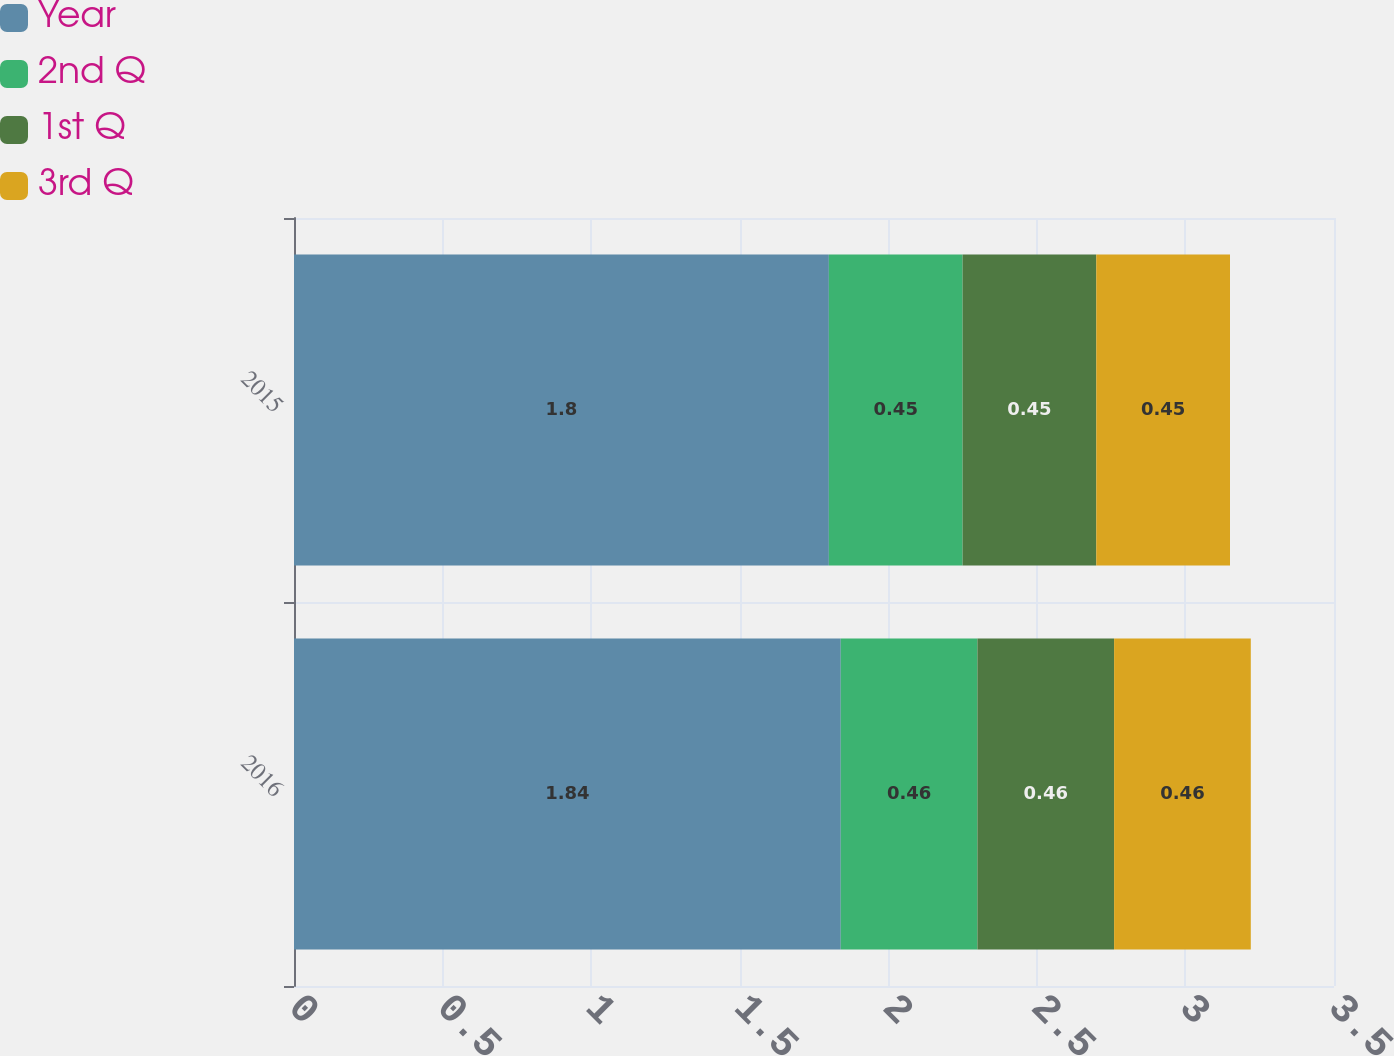Convert chart to OTSL. <chart><loc_0><loc_0><loc_500><loc_500><stacked_bar_chart><ecel><fcel>2016<fcel>2015<nl><fcel>Year<fcel>1.84<fcel>1.8<nl><fcel>2nd Q<fcel>0.46<fcel>0.45<nl><fcel>1st Q<fcel>0.46<fcel>0.45<nl><fcel>3rd Q<fcel>0.46<fcel>0.45<nl></chart> 